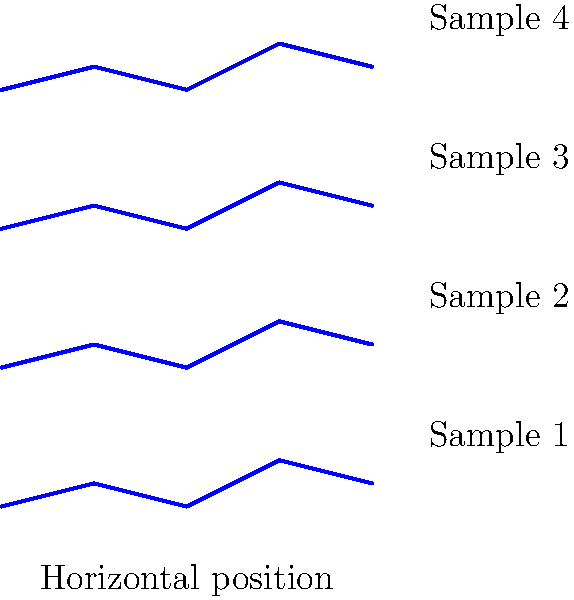As a language specialist interpreting testimonies, you are presented with four handwriting samples from different victim statements. Based on the graphical representation of these samples, which one exhibits the most consistent baseline and would likely be considered the most stable in terms of emotional state during writing? To determine which handwriting sample exhibits the most consistent baseline and indicates the most stable emotional state, we need to analyze each sample's characteristics:

1. Examine the baseline of each sample:
   - Sample 1 (bottom): Shows significant fluctuations in the baseline
   - Sample 2: Has moderate variations in the baseline
   - Sample 3: Displays some inconsistencies in the baseline
   - Sample 4 (top): Demonstrates the most consistent and level baseline

2. Consider the implications of baseline consistency:
   - A consistent baseline often indicates a more stable emotional state during writing
   - Fluctuations in the baseline can suggest emotional instability or stress

3. Evaluate the overall appearance:
   - Sample 4 has the most uniform appearance in terms of height and regularity
   - Other samples show more variability in their overall structure

4. Interpret the findings:
   - Sample 4 exhibits the most consistent baseline and regularity
   - This suggests that the writer of Sample 4 was likely in the most stable emotional state during writing

5. Consider the limitations:
   - A full handwriting analysis would require more detailed samples and context
   - This simplified representation provides a basic comparison for demonstration purposes

Based on this analysis, Sample 4 (the topmost sample) demonstrates the most consistent baseline and regularity, indicating the most stable emotional state during writing.
Answer: Sample 4 